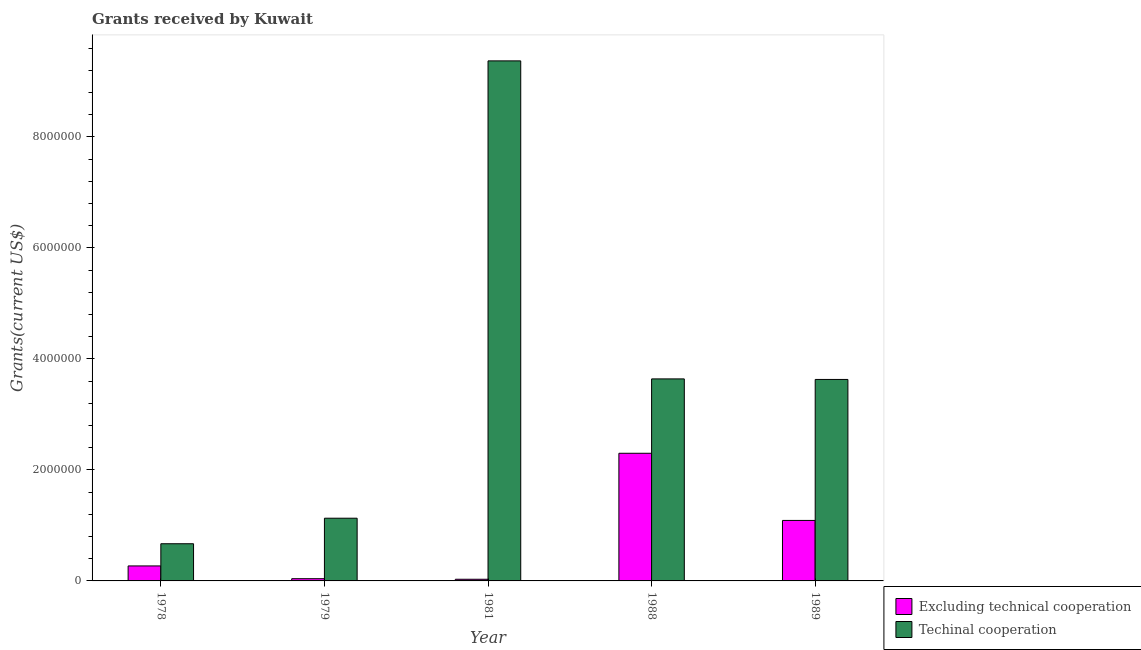How many different coloured bars are there?
Give a very brief answer. 2. How many groups of bars are there?
Ensure brevity in your answer.  5. How many bars are there on the 5th tick from the right?
Provide a short and direct response. 2. What is the label of the 2nd group of bars from the left?
Offer a very short reply. 1979. What is the amount of grants received(excluding technical cooperation) in 1989?
Provide a short and direct response. 1.09e+06. Across all years, what is the maximum amount of grants received(including technical cooperation)?
Provide a short and direct response. 9.37e+06. Across all years, what is the minimum amount of grants received(including technical cooperation)?
Give a very brief answer. 6.70e+05. In which year was the amount of grants received(including technical cooperation) maximum?
Provide a short and direct response. 1981. In which year was the amount of grants received(excluding technical cooperation) minimum?
Provide a short and direct response. 1981. What is the total amount of grants received(including technical cooperation) in the graph?
Ensure brevity in your answer.  1.84e+07. What is the difference between the amount of grants received(including technical cooperation) in 1978 and that in 1979?
Provide a short and direct response. -4.60e+05. What is the difference between the amount of grants received(including technical cooperation) in 1978 and the amount of grants received(excluding technical cooperation) in 1988?
Your answer should be very brief. -2.97e+06. What is the average amount of grants received(including technical cooperation) per year?
Provide a short and direct response. 3.69e+06. In how many years, is the amount of grants received(including technical cooperation) greater than 5600000 US$?
Offer a terse response. 1. What is the ratio of the amount of grants received(excluding technical cooperation) in 1981 to that in 1989?
Make the answer very short. 0.03. Is the difference between the amount of grants received(excluding technical cooperation) in 1978 and 1979 greater than the difference between the amount of grants received(including technical cooperation) in 1978 and 1979?
Your response must be concise. No. What is the difference between the highest and the second highest amount of grants received(excluding technical cooperation)?
Your response must be concise. 1.21e+06. What is the difference between the highest and the lowest amount of grants received(including technical cooperation)?
Make the answer very short. 8.70e+06. What does the 2nd bar from the left in 1979 represents?
Keep it short and to the point. Techinal cooperation. What does the 1st bar from the right in 1981 represents?
Your answer should be compact. Techinal cooperation. How many years are there in the graph?
Make the answer very short. 5. What is the difference between two consecutive major ticks on the Y-axis?
Your answer should be very brief. 2.00e+06. Does the graph contain any zero values?
Give a very brief answer. No. Does the graph contain grids?
Your answer should be compact. No. What is the title of the graph?
Offer a very short reply. Grants received by Kuwait. Does "State government" appear as one of the legend labels in the graph?
Offer a terse response. No. What is the label or title of the X-axis?
Your answer should be compact. Year. What is the label or title of the Y-axis?
Give a very brief answer. Grants(current US$). What is the Grants(current US$) of Techinal cooperation in 1978?
Offer a very short reply. 6.70e+05. What is the Grants(current US$) of Techinal cooperation in 1979?
Give a very brief answer. 1.13e+06. What is the Grants(current US$) of Excluding technical cooperation in 1981?
Ensure brevity in your answer.  3.00e+04. What is the Grants(current US$) of Techinal cooperation in 1981?
Provide a short and direct response. 9.37e+06. What is the Grants(current US$) of Excluding technical cooperation in 1988?
Offer a very short reply. 2.30e+06. What is the Grants(current US$) in Techinal cooperation in 1988?
Offer a very short reply. 3.64e+06. What is the Grants(current US$) in Excluding technical cooperation in 1989?
Ensure brevity in your answer.  1.09e+06. What is the Grants(current US$) of Techinal cooperation in 1989?
Make the answer very short. 3.63e+06. Across all years, what is the maximum Grants(current US$) of Excluding technical cooperation?
Ensure brevity in your answer.  2.30e+06. Across all years, what is the maximum Grants(current US$) of Techinal cooperation?
Provide a short and direct response. 9.37e+06. Across all years, what is the minimum Grants(current US$) in Excluding technical cooperation?
Your response must be concise. 3.00e+04. Across all years, what is the minimum Grants(current US$) of Techinal cooperation?
Your answer should be compact. 6.70e+05. What is the total Grants(current US$) of Excluding technical cooperation in the graph?
Give a very brief answer. 3.73e+06. What is the total Grants(current US$) in Techinal cooperation in the graph?
Offer a terse response. 1.84e+07. What is the difference between the Grants(current US$) in Techinal cooperation in 1978 and that in 1979?
Offer a terse response. -4.60e+05. What is the difference between the Grants(current US$) of Excluding technical cooperation in 1978 and that in 1981?
Ensure brevity in your answer.  2.40e+05. What is the difference between the Grants(current US$) of Techinal cooperation in 1978 and that in 1981?
Your answer should be compact. -8.70e+06. What is the difference between the Grants(current US$) in Excluding technical cooperation in 1978 and that in 1988?
Offer a very short reply. -2.03e+06. What is the difference between the Grants(current US$) in Techinal cooperation in 1978 and that in 1988?
Offer a terse response. -2.97e+06. What is the difference between the Grants(current US$) in Excluding technical cooperation in 1978 and that in 1989?
Your answer should be compact. -8.20e+05. What is the difference between the Grants(current US$) in Techinal cooperation in 1978 and that in 1989?
Offer a terse response. -2.96e+06. What is the difference between the Grants(current US$) in Excluding technical cooperation in 1979 and that in 1981?
Provide a short and direct response. 10000. What is the difference between the Grants(current US$) of Techinal cooperation in 1979 and that in 1981?
Your answer should be compact. -8.24e+06. What is the difference between the Grants(current US$) in Excluding technical cooperation in 1979 and that in 1988?
Keep it short and to the point. -2.26e+06. What is the difference between the Grants(current US$) of Techinal cooperation in 1979 and that in 1988?
Your response must be concise. -2.51e+06. What is the difference between the Grants(current US$) of Excluding technical cooperation in 1979 and that in 1989?
Make the answer very short. -1.05e+06. What is the difference between the Grants(current US$) in Techinal cooperation in 1979 and that in 1989?
Offer a terse response. -2.50e+06. What is the difference between the Grants(current US$) in Excluding technical cooperation in 1981 and that in 1988?
Provide a succinct answer. -2.27e+06. What is the difference between the Grants(current US$) of Techinal cooperation in 1981 and that in 1988?
Your answer should be very brief. 5.73e+06. What is the difference between the Grants(current US$) in Excluding technical cooperation in 1981 and that in 1989?
Your answer should be compact. -1.06e+06. What is the difference between the Grants(current US$) of Techinal cooperation in 1981 and that in 1989?
Your answer should be compact. 5.74e+06. What is the difference between the Grants(current US$) of Excluding technical cooperation in 1988 and that in 1989?
Your answer should be compact. 1.21e+06. What is the difference between the Grants(current US$) of Techinal cooperation in 1988 and that in 1989?
Offer a terse response. 10000. What is the difference between the Grants(current US$) of Excluding technical cooperation in 1978 and the Grants(current US$) of Techinal cooperation in 1979?
Ensure brevity in your answer.  -8.60e+05. What is the difference between the Grants(current US$) in Excluding technical cooperation in 1978 and the Grants(current US$) in Techinal cooperation in 1981?
Provide a short and direct response. -9.10e+06. What is the difference between the Grants(current US$) of Excluding technical cooperation in 1978 and the Grants(current US$) of Techinal cooperation in 1988?
Ensure brevity in your answer.  -3.37e+06. What is the difference between the Grants(current US$) of Excluding technical cooperation in 1978 and the Grants(current US$) of Techinal cooperation in 1989?
Offer a very short reply. -3.36e+06. What is the difference between the Grants(current US$) of Excluding technical cooperation in 1979 and the Grants(current US$) of Techinal cooperation in 1981?
Make the answer very short. -9.33e+06. What is the difference between the Grants(current US$) of Excluding technical cooperation in 1979 and the Grants(current US$) of Techinal cooperation in 1988?
Your answer should be very brief. -3.60e+06. What is the difference between the Grants(current US$) of Excluding technical cooperation in 1979 and the Grants(current US$) of Techinal cooperation in 1989?
Make the answer very short. -3.59e+06. What is the difference between the Grants(current US$) of Excluding technical cooperation in 1981 and the Grants(current US$) of Techinal cooperation in 1988?
Your answer should be compact. -3.61e+06. What is the difference between the Grants(current US$) of Excluding technical cooperation in 1981 and the Grants(current US$) of Techinal cooperation in 1989?
Your response must be concise. -3.60e+06. What is the difference between the Grants(current US$) in Excluding technical cooperation in 1988 and the Grants(current US$) in Techinal cooperation in 1989?
Keep it short and to the point. -1.33e+06. What is the average Grants(current US$) of Excluding technical cooperation per year?
Give a very brief answer. 7.46e+05. What is the average Grants(current US$) in Techinal cooperation per year?
Make the answer very short. 3.69e+06. In the year 1978, what is the difference between the Grants(current US$) of Excluding technical cooperation and Grants(current US$) of Techinal cooperation?
Provide a short and direct response. -4.00e+05. In the year 1979, what is the difference between the Grants(current US$) of Excluding technical cooperation and Grants(current US$) of Techinal cooperation?
Your response must be concise. -1.09e+06. In the year 1981, what is the difference between the Grants(current US$) of Excluding technical cooperation and Grants(current US$) of Techinal cooperation?
Your answer should be very brief. -9.34e+06. In the year 1988, what is the difference between the Grants(current US$) in Excluding technical cooperation and Grants(current US$) in Techinal cooperation?
Give a very brief answer. -1.34e+06. In the year 1989, what is the difference between the Grants(current US$) in Excluding technical cooperation and Grants(current US$) in Techinal cooperation?
Give a very brief answer. -2.54e+06. What is the ratio of the Grants(current US$) in Excluding technical cooperation in 1978 to that in 1979?
Provide a short and direct response. 6.75. What is the ratio of the Grants(current US$) of Techinal cooperation in 1978 to that in 1979?
Your answer should be very brief. 0.59. What is the ratio of the Grants(current US$) of Techinal cooperation in 1978 to that in 1981?
Give a very brief answer. 0.07. What is the ratio of the Grants(current US$) in Excluding technical cooperation in 1978 to that in 1988?
Provide a succinct answer. 0.12. What is the ratio of the Grants(current US$) in Techinal cooperation in 1978 to that in 1988?
Ensure brevity in your answer.  0.18. What is the ratio of the Grants(current US$) in Excluding technical cooperation in 1978 to that in 1989?
Provide a short and direct response. 0.25. What is the ratio of the Grants(current US$) of Techinal cooperation in 1978 to that in 1989?
Make the answer very short. 0.18. What is the ratio of the Grants(current US$) in Techinal cooperation in 1979 to that in 1981?
Offer a very short reply. 0.12. What is the ratio of the Grants(current US$) in Excluding technical cooperation in 1979 to that in 1988?
Give a very brief answer. 0.02. What is the ratio of the Grants(current US$) in Techinal cooperation in 1979 to that in 1988?
Offer a terse response. 0.31. What is the ratio of the Grants(current US$) of Excluding technical cooperation in 1979 to that in 1989?
Your answer should be compact. 0.04. What is the ratio of the Grants(current US$) of Techinal cooperation in 1979 to that in 1989?
Provide a succinct answer. 0.31. What is the ratio of the Grants(current US$) of Excluding technical cooperation in 1981 to that in 1988?
Keep it short and to the point. 0.01. What is the ratio of the Grants(current US$) in Techinal cooperation in 1981 to that in 1988?
Provide a succinct answer. 2.57. What is the ratio of the Grants(current US$) in Excluding technical cooperation in 1981 to that in 1989?
Offer a terse response. 0.03. What is the ratio of the Grants(current US$) in Techinal cooperation in 1981 to that in 1989?
Ensure brevity in your answer.  2.58. What is the ratio of the Grants(current US$) of Excluding technical cooperation in 1988 to that in 1989?
Offer a terse response. 2.11. What is the ratio of the Grants(current US$) of Techinal cooperation in 1988 to that in 1989?
Make the answer very short. 1. What is the difference between the highest and the second highest Grants(current US$) in Excluding technical cooperation?
Provide a short and direct response. 1.21e+06. What is the difference between the highest and the second highest Grants(current US$) in Techinal cooperation?
Offer a very short reply. 5.73e+06. What is the difference between the highest and the lowest Grants(current US$) in Excluding technical cooperation?
Keep it short and to the point. 2.27e+06. What is the difference between the highest and the lowest Grants(current US$) in Techinal cooperation?
Your answer should be compact. 8.70e+06. 